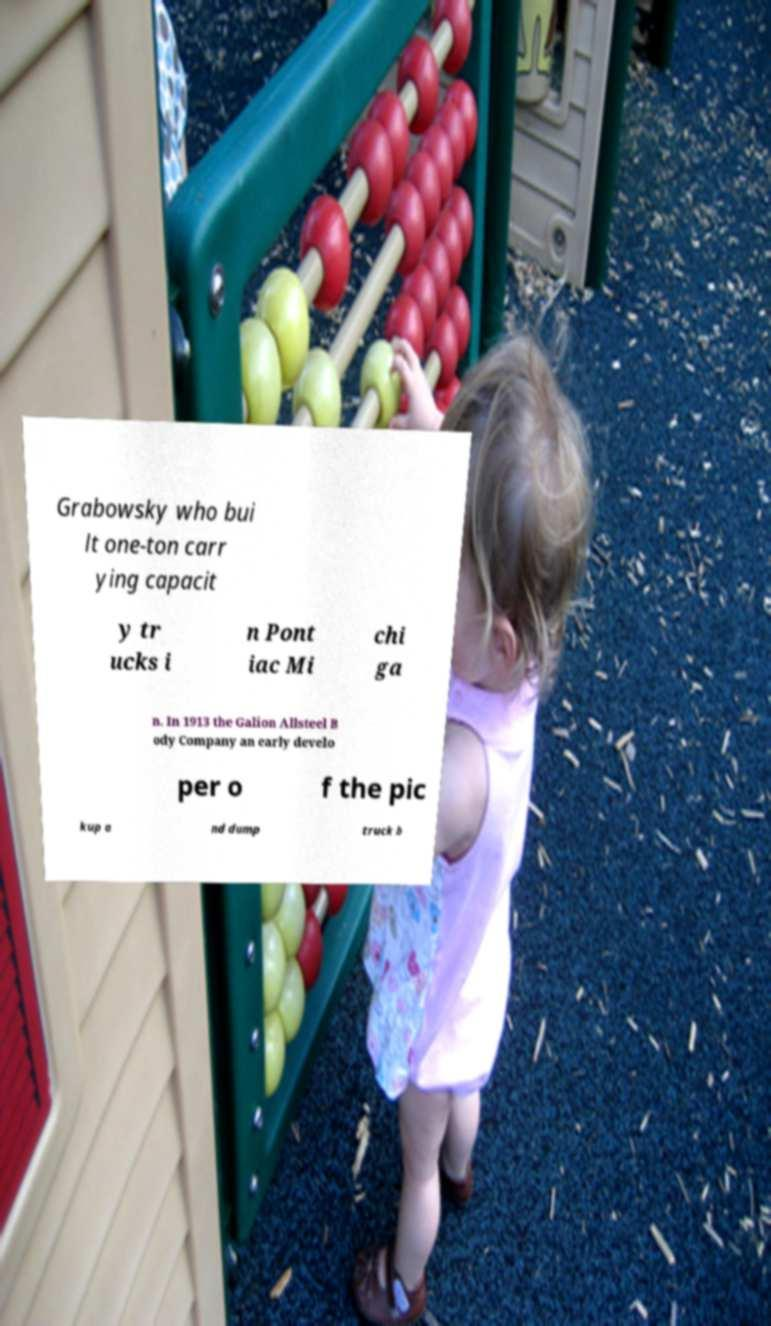There's text embedded in this image that I need extracted. Can you transcribe it verbatim? Grabowsky who bui lt one-ton carr ying capacit y tr ucks i n Pont iac Mi chi ga n. In 1913 the Galion Allsteel B ody Company an early develo per o f the pic kup a nd dump truck b 